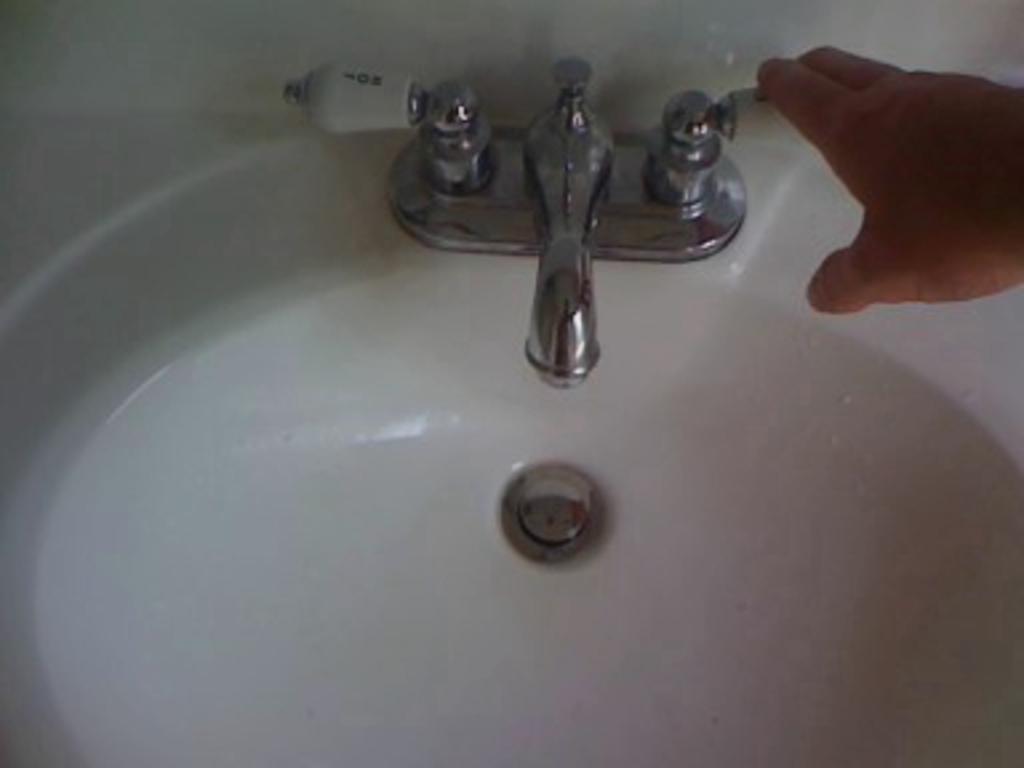Describe this image in one or two sentences. In the image we can see some sink. In the top right corner of the image we can see a hand. 